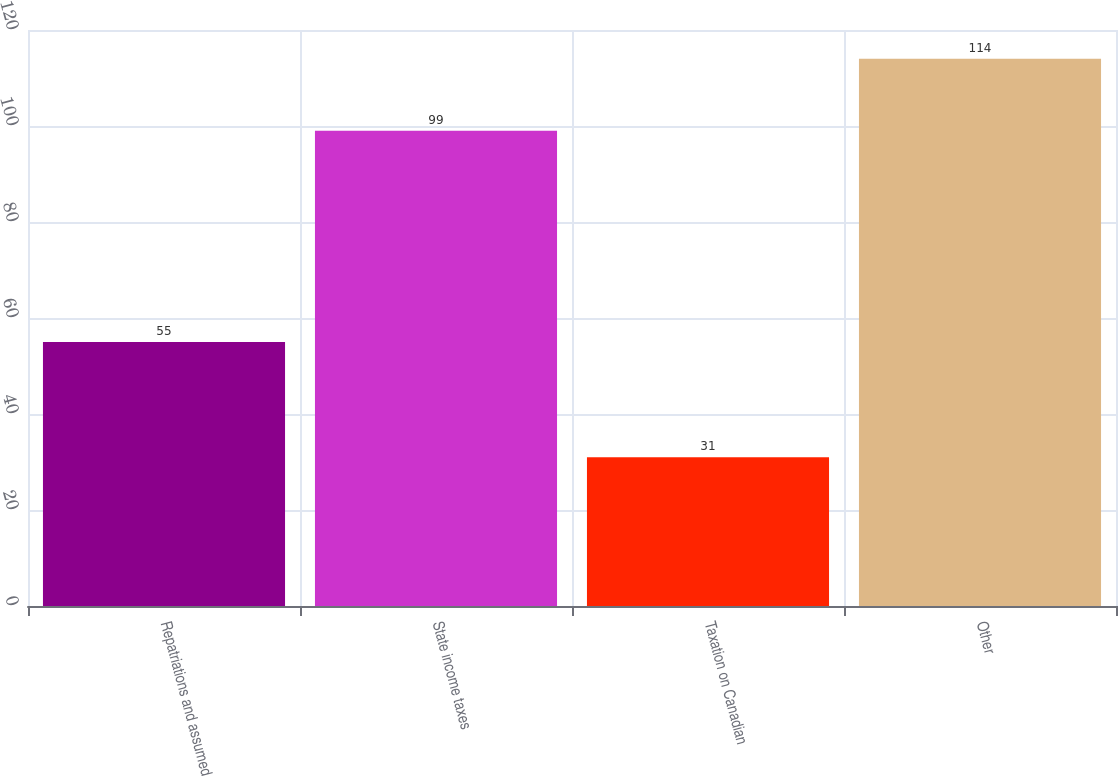Convert chart. <chart><loc_0><loc_0><loc_500><loc_500><bar_chart><fcel>Repatriations and assumed<fcel>State income taxes<fcel>Taxation on Canadian<fcel>Other<nl><fcel>55<fcel>99<fcel>31<fcel>114<nl></chart> 